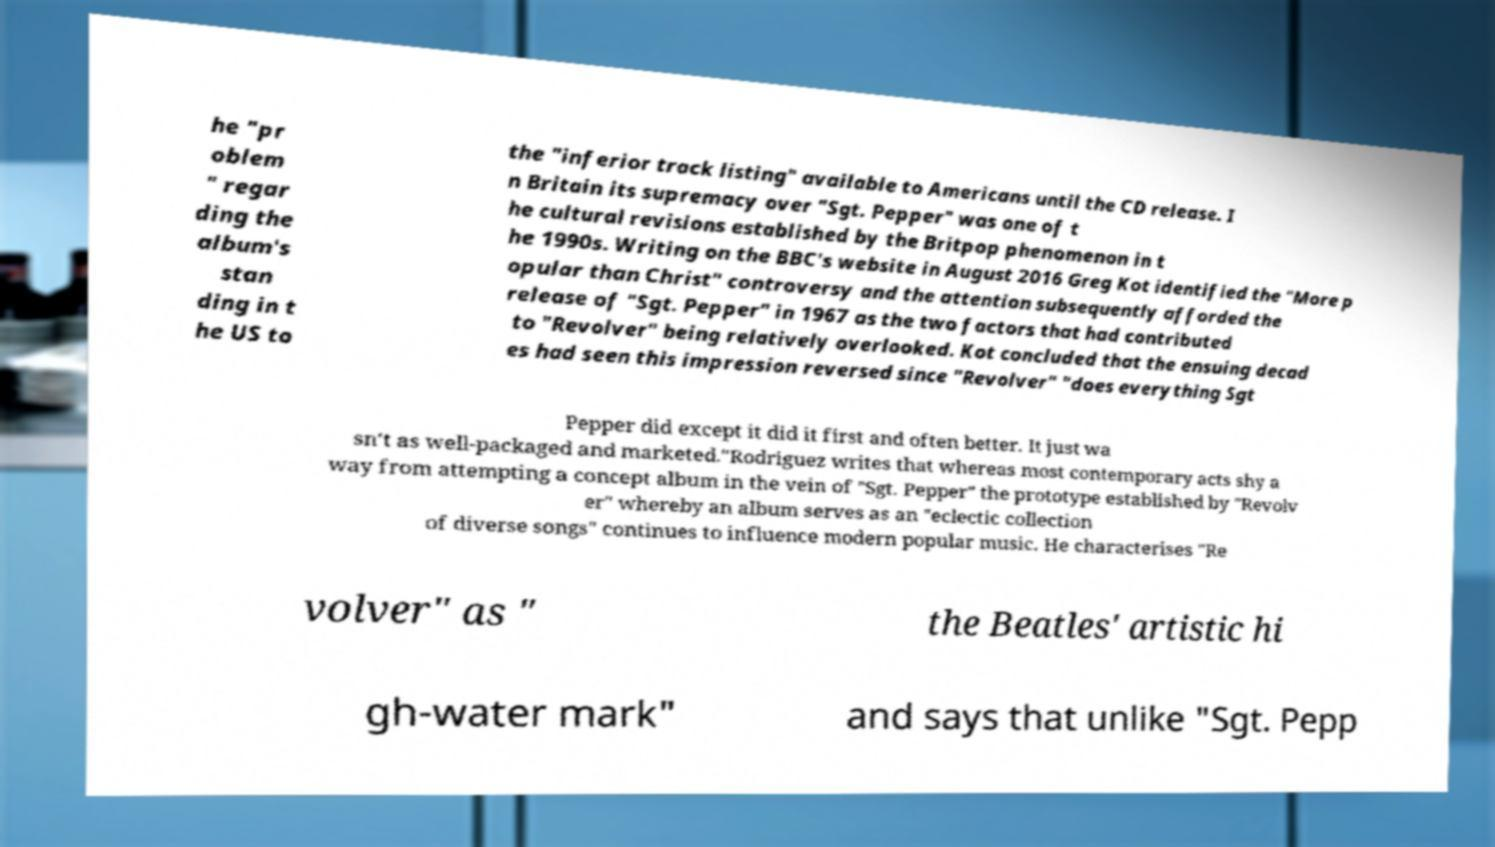I need the written content from this picture converted into text. Can you do that? he "pr oblem " regar ding the album's stan ding in t he US to the "inferior track listing" available to Americans until the CD release. I n Britain its supremacy over "Sgt. Pepper" was one of t he cultural revisions established by the Britpop phenomenon in t he 1990s. Writing on the BBC's website in August 2016 Greg Kot identified the "More p opular than Christ" controversy and the attention subsequently afforded the release of "Sgt. Pepper" in 1967 as the two factors that had contributed to "Revolver" being relatively overlooked. Kot concluded that the ensuing decad es had seen this impression reversed since "Revolver" "does everything Sgt Pepper did except it did it first and often better. It just wa sn't as well-packaged and marketed."Rodriguez writes that whereas most contemporary acts shy a way from attempting a concept album in the vein of "Sgt. Pepper" the prototype established by "Revolv er" whereby an album serves as an "eclectic collection of diverse songs" continues to influence modern popular music. He characterises "Re volver" as " the Beatles' artistic hi gh-water mark" and says that unlike "Sgt. Pepp 